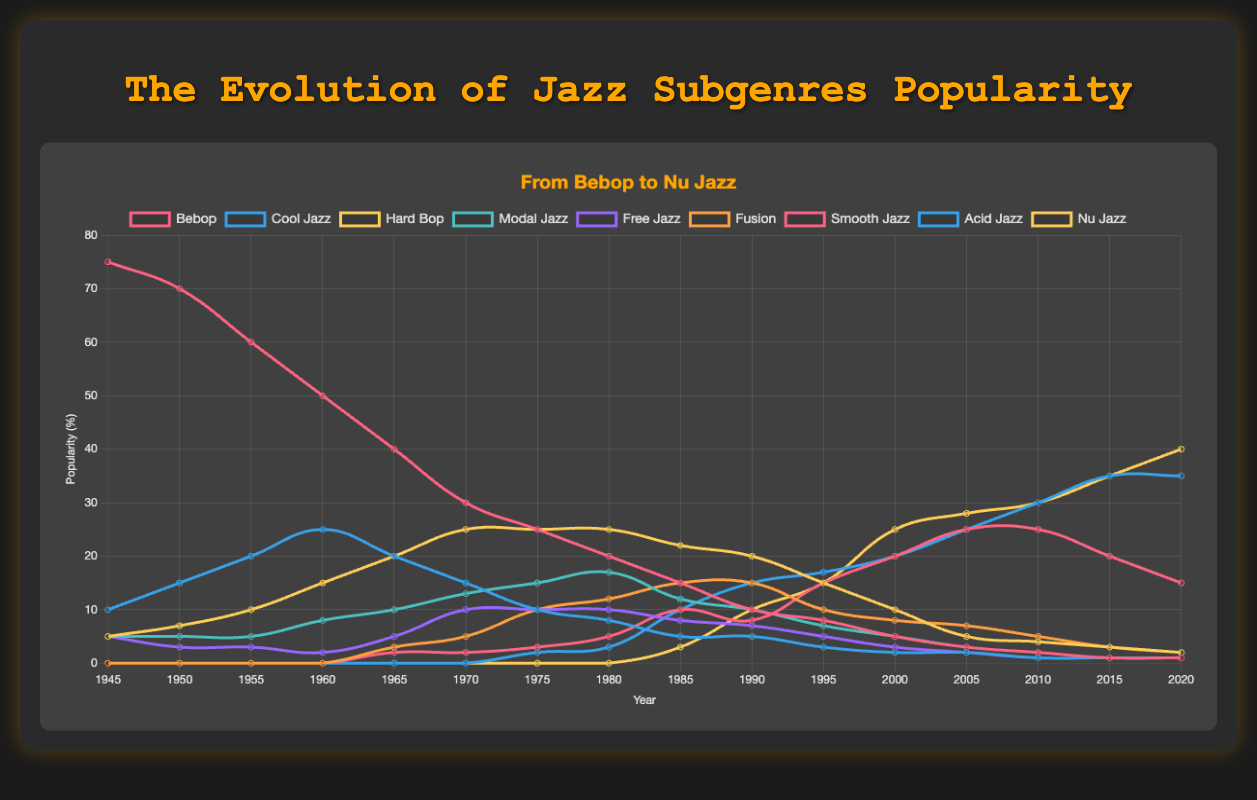What was the most popular jazz subgenre in 1945? Looking at the graph, the highest line in 1945 is Bebop, reaching a peak of 75 in popularity.
Answer: Bebop How did the popularity of Bebop change from 1945 to 1960? Bebop's popularity decreased from 75 in 1945 to 50 in 1960.
Answer: Decreased Which subgenres had a popularity value of 10 in 1970? Checking for 1970, Hard Bop had a value of 25, Bebop 30, Cool Jazz 15, Free Jazz 10, Modal Jazz 13, and Fusion 5. Filtering reveals only Free Jazz reached 10.
Answer: Free Jazz What is the difference in popularity between Cool Jazz and Acid Jazz in 2010? In 2010, Cool Jazz has a popularity of 1 while Acid Jazz has 30. The difference is
Answer: 29 Which subgenre had the greatest rise in popularity between 1990 and 2000? Comparing the values in 1990 and 2000, Nu Jazz had an increase from 10 to 25, a rise of 15 points which is higher than any other subgenre.
Answer: Nu Jazz Comparing Modal Jazz and Smooth Jazz, which was more popular in 2015? In 2015, Modal Jazz is at 1, while Smooth Jazz has a popularity of 20.
Answer: Smooth Jazz From 2000 to 2020, which subgenre showed steady growth? Between 2000 and 2020, Acid Jazz increased steadily from 20 in 2000 to 35 in 2020.
Answer: Acid Jazz How many subgenres reached a peak popularity of 25 at any point in time? Bebop (75), Cool Jazz (25), Hard Bop (25), Smooth Jazz (25), Acid Jazz (35), and Nu Jazz (40), overturns that Smooth Jazz got 25 in 2005 and Acid Jazz hit 25 in 2005.
Answer: 2 Which subgenre maintained a popularity of 5 or more from 1945 to 2005? Hard Bop maintained a popularity value over 5 consistently from 1945 (5) to 2005 (5).
Answer: Hard Bop 